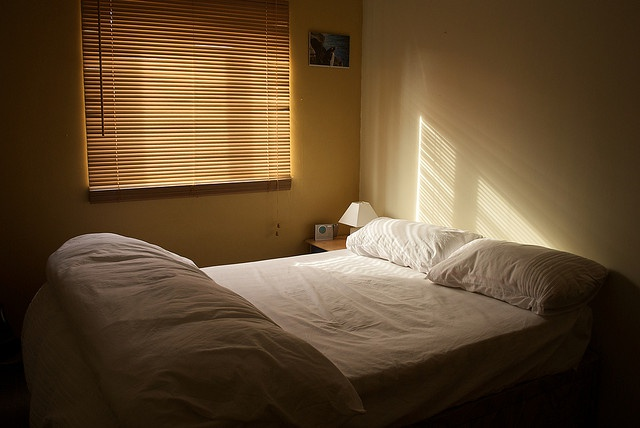Describe the objects in this image and their specific colors. I can see bed in black, gray, and maroon tones and clock in black, maroon, and gray tones in this image. 